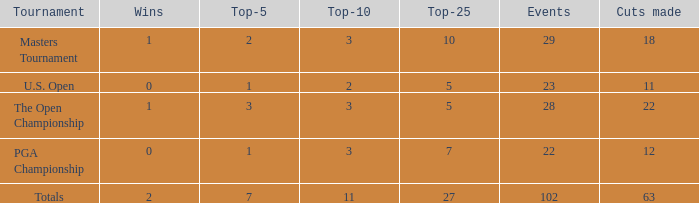How many top 10s associated with 3 top 5s and under 22 cuts made? None. 